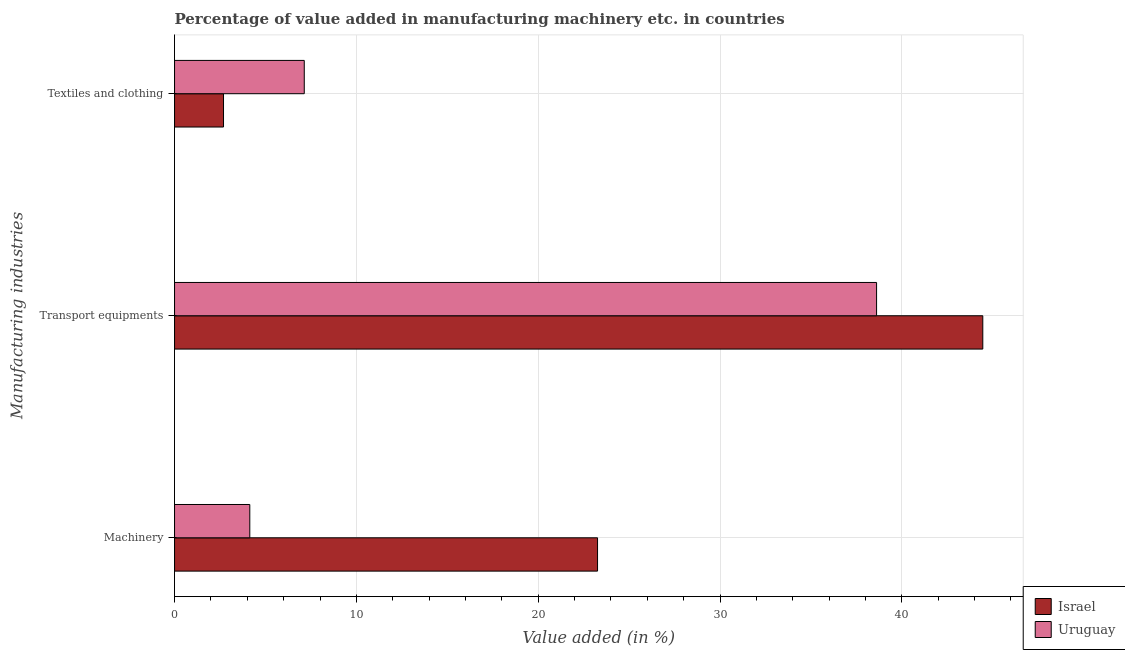How many different coloured bars are there?
Ensure brevity in your answer.  2. How many bars are there on the 2nd tick from the top?
Provide a short and direct response. 2. What is the label of the 2nd group of bars from the top?
Provide a short and direct response. Transport equipments. What is the value added in manufacturing machinery in Uruguay?
Offer a very short reply. 4.14. Across all countries, what is the maximum value added in manufacturing machinery?
Keep it short and to the point. 23.26. Across all countries, what is the minimum value added in manufacturing machinery?
Ensure brevity in your answer.  4.14. In which country was the value added in manufacturing textile and clothing maximum?
Make the answer very short. Uruguay. In which country was the value added in manufacturing transport equipments minimum?
Provide a succinct answer. Uruguay. What is the total value added in manufacturing transport equipments in the graph?
Give a very brief answer. 83.06. What is the difference between the value added in manufacturing textile and clothing in Uruguay and that in Israel?
Provide a succinct answer. 4.44. What is the difference between the value added in manufacturing transport equipments in Israel and the value added in manufacturing machinery in Uruguay?
Offer a terse response. 40.31. What is the average value added in manufacturing textile and clothing per country?
Provide a short and direct response. 4.91. What is the difference between the value added in manufacturing textile and clothing and value added in manufacturing transport equipments in Uruguay?
Keep it short and to the point. -31.47. What is the ratio of the value added in manufacturing transport equipments in Uruguay to that in Israel?
Your answer should be compact. 0.87. What is the difference between the highest and the second highest value added in manufacturing textile and clothing?
Your response must be concise. 4.44. What is the difference between the highest and the lowest value added in manufacturing transport equipments?
Provide a succinct answer. 5.84. Is it the case that in every country, the sum of the value added in manufacturing machinery and value added in manufacturing transport equipments is greater than the value added in manufacturing textile and clothing?
Offer a very short reply. Yes. Are all the bars in the graph horizontal?
Your answer should be very brief. Yes. How many countries are there in the graph?
Provide a short and direct response. 2. Does the graph contain any zero values?
Your answer should be compact. No. Where does the legend appear in the graph?
Your answer should be compact. Bottom right. How are the legend labels stacked?
Your answer should be very brief. Vertical. What is the title of the graph?
Make the answer very short. Percentage of value added in manufacturing machinery etc. in countries. Does "Jordan" appear as one of the legend labels in the graph?
Make the answer very short. No. What is the label or title of the X-axis?
Offer a very short reply. Value added (in %). What is the label or title of the Y-axis?
Your answer should be compact. Manufacturing industries. What is the Value added (in %) of Israel in Machinery?
Provide a short and direct response. 23.26. What is the Value added (in %) of Uruguay in Machinery?
Your answer should be compact. 4.14. What is the Value added (in %) in Israel in Transport equipments?
Your answer should be very brief. 44.45. What is the Value added (in %) in Uruguay in Transport equipments?
Make the answer very short. 38.61. What is the Value added (in %) in Israel in Textiles and clothing?
Ensure brevity in your answer.  2.69. What is the Value added (in %) in Uruguay in Textiles and clothing?
Offer a terse response. 7.13. Across all Manufacturing industries, what is the maximum Value added (in %) in Israel?
Give a very brief answer. 44.45. Across all Manufacturing industries, what is the maximum Value added (in %) in Uruguay?
Keep it short and to the point. 38.61. Across all Manufacturing industries, what is the minimum Value added (in %) of Israel?
Offer a very short reply. 2.69. Across all Manufacturing industries, what is the minimum Value added (in %) in Uruguay?
Give a very brief answer. 4.14. What is the total Value added (in %) of Israel in the graph?
Offer a very short reply. 70.41. What is the total Value added (in %) of Uruguay in the graph?
Your response must be concise. 49.88. What is the difference between the Value added (in %) in Israel in Machinery and that in Transport equipments?
Give a very brief answer. -21.19. What is the difference between the Value added (in %) of Uruguay in Machinery and that in Transport equipments?
Make the answer very short. -34.47. What is the difference between the Value added (in %) in Israel in Machinery and that in Textiles and clothing?
Make the answer very short. 20.57. What is the difference between the Value added (in %) of Uruguay in Machinery and that in Textiles and clothing?
Provide a succinct answer. -3. What is the difference between the Value added (in %) in Israel in Transport equipments and that in Textiles and clothing?
Provide a short and direct response. 41.76. What is the difference between the Value added (in %) of Uruguay in Transport equipments and that in Textiles and clothing?
Ensure brevity in your answer.  31.47. What is the difference between the Value added (in %) in Israel in Machinery and the Value added (in %) in Uruguay in Transport equipments?
Make the answer very short. -15.35. What is the difference between the Value added (in %) of Israel in Machinery and the Value added (in %) of Uruguay in Textiles and clothing?
Your answer should be very brief. 16.13. What is the difference between the Value added (in %) in Israel in Transport equipments and the Value added (in %) in Uruguay in Textiles and clothing?
Your answer should be compact. 37.32. What is the average Value added (in %) of Israel per Manufacturing industries?
Your answer should be very brief. 23.47. What is the average Value added (in %) in Uruguay per Manufacturing industries?
Provide a succinct answer. 16.63. What is the difference between the Value added (in %) in Israel and Value added (in %) in Uruguay in Machinery?
Offer a terse response. 19.13. What is the difference between the Value added (in %) of Israel and Value added (in %) of Uruguay in Transport equipments?
Your answer should be compact. 5.84. What is the difference between the Value added (in %) in Israel and Value added (in %) in Uruguay in Textiles and clothing?
Provide a short and direct response. -4.44. What is the ratio of the Value added (in %) of Israel in Machinery to that in Transport equipments?
Offer a very short reply. 0.52. What is the ratio of the Value added (in %) in Uruguay in Machinery to that in Transport equipments?
Offer a very short reply. 0.11. What is the ratio of the Value added (in %) of Israel in Machinery to that in Textiles and clothing?
Offer a very short reply. 8.64. What is the ratio of the Value added (in %) of Uruguay in Machinery to that in Textiles and clothing?
Your answer should be very brief. 0.58. What is the ratio of the Value added (in %) in Israel in Transport equipments to that in Textiles and clothing?
Offer a very short reply. 16.51. What is the ratio of the Value added (in %) of Uruguay in Transport equipments to that in Textiles and clothing?
Your response must be concise. 5.41. What is the difference between the highest and the second highest Value added (in %) in Israel?
Offer a very short reply. 21.19. What is the difference between the highest and the second highest Value added (in %) in Uruguay?
Your answer should be very brief. 31.47. What is the difference between the highest and the lowest Value added (in %) in Israel?
Ensure brevity in your answer.  41.76. What is the difference between the highest and the lowest Value added (in %) in Uruguay?
Provide a short and direct response. 34.47. 